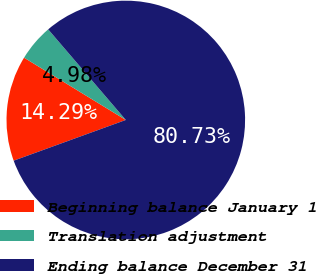Convert chart to OTSL. <chart><loc_0><loc_0><loc_500><loc_500><pie_chart><fcel>Beginning balance January 1<fcel>Translation adjustment<fcel>Ending balance December 31<nl><fcel>14.29%<fcel>4.98%<fcel>80.73%<nl></chart> 